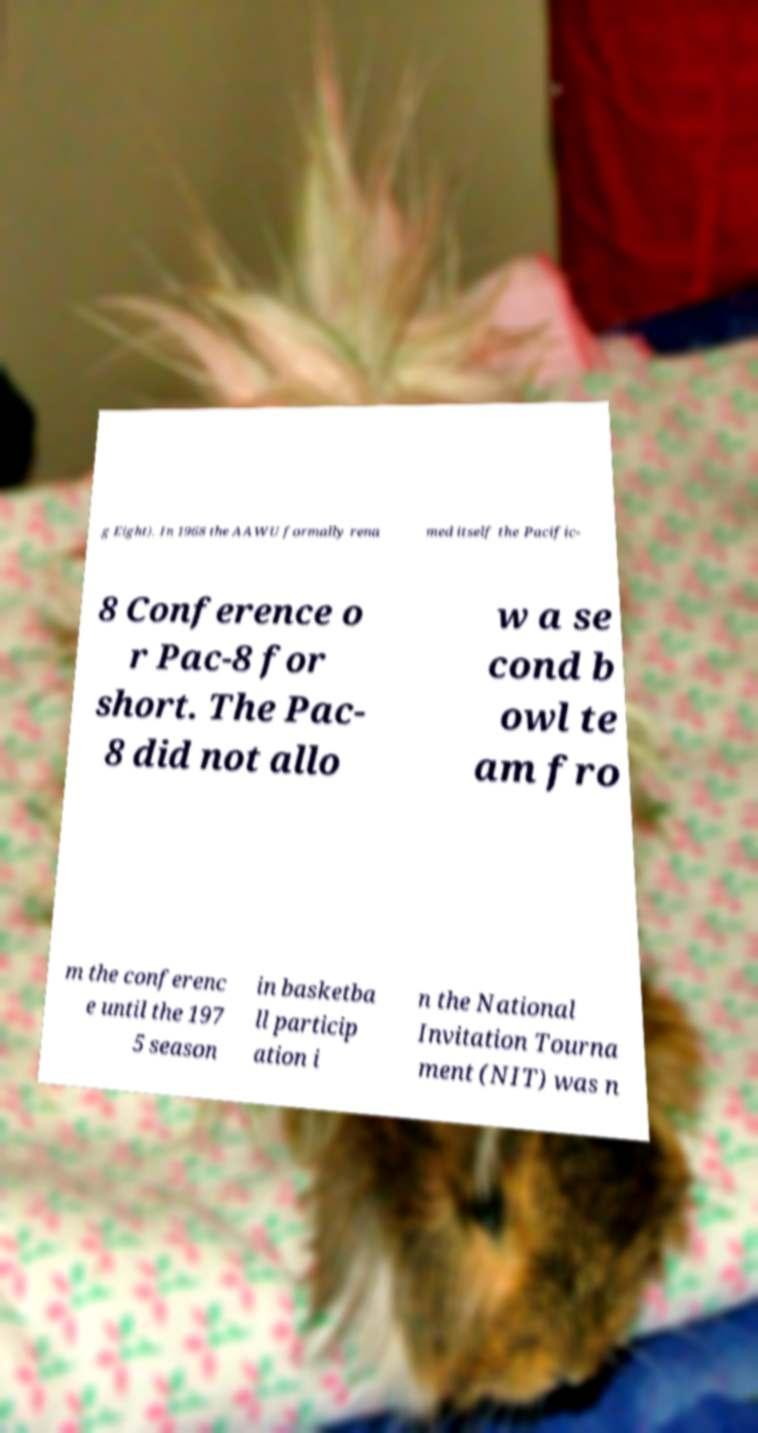For documentation purposes, I need the text within this image transcribed. Could you provide that? g Eight). In 1968 the AAWU formally rena med itself the Pacific- 8 Conference o r Pac-8 for short. The Pac- 8 did not allo w a se cond b owl te am fro m the conferenc e until the 197 5 season in basketba ll particip ation i n the National Invitation Tourna ment (NIT) was n 